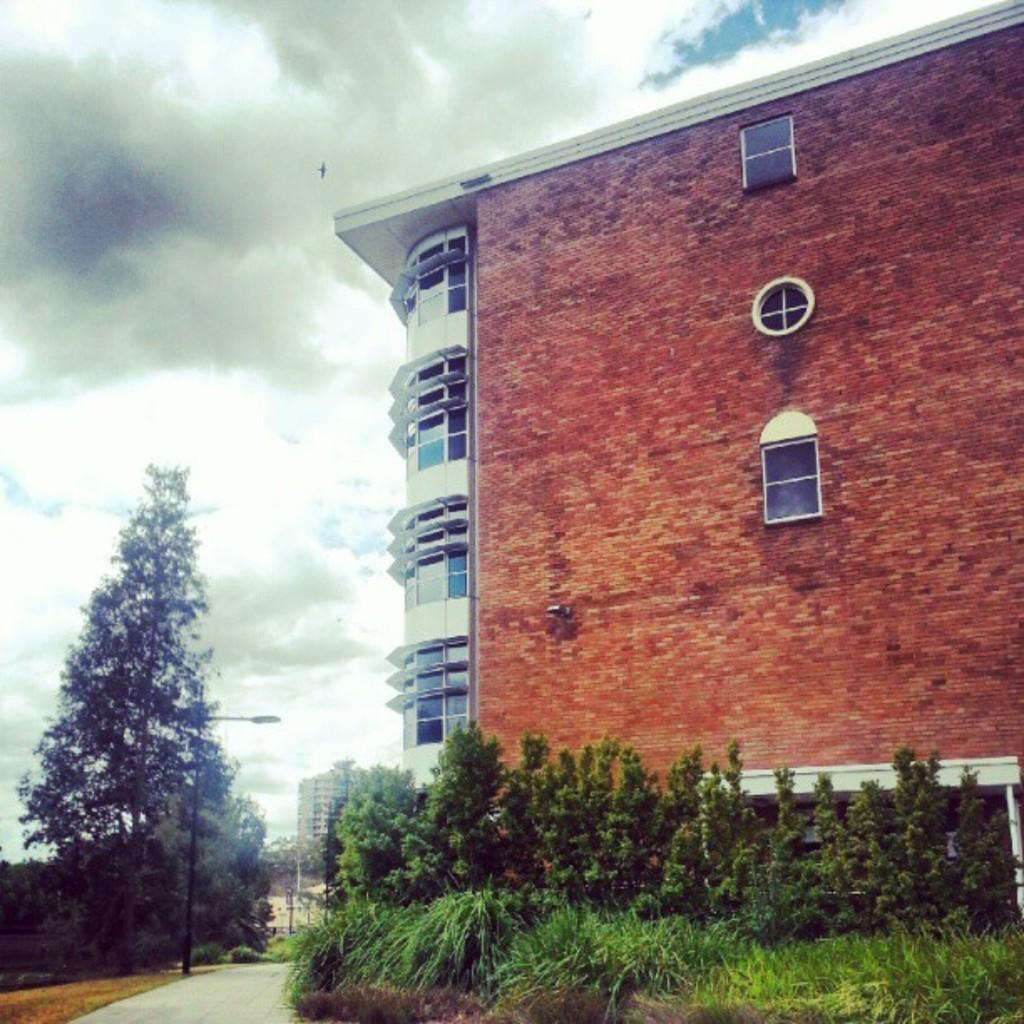How would you summarize this image in a sentence or two? In this picture I can see there is a building here and it has few glass windows and there are plants and trees here and the sky is clear. 